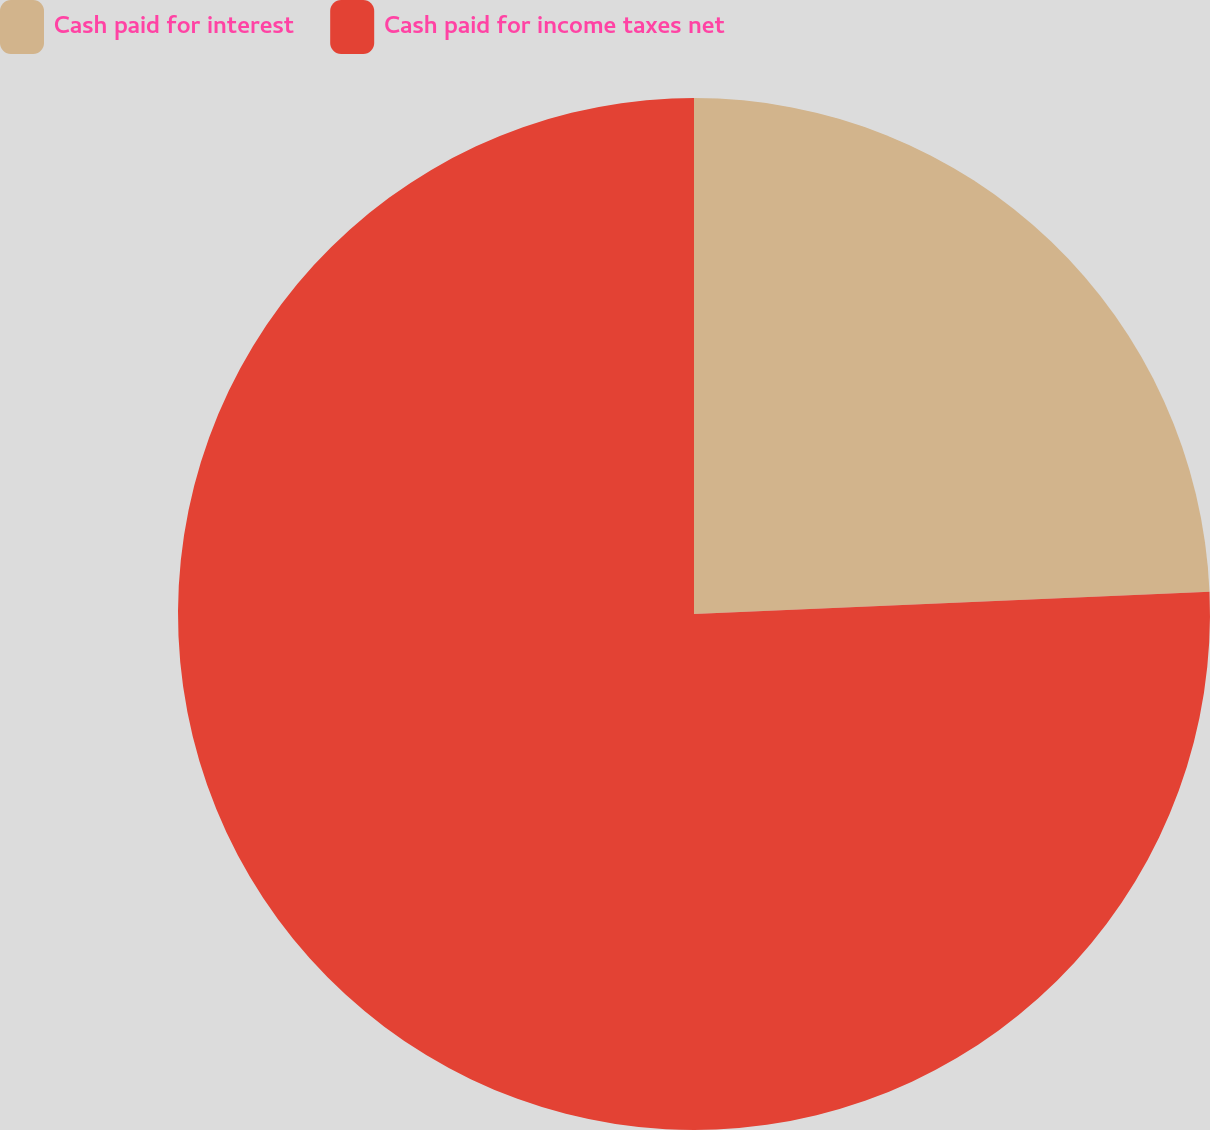Convert chart to OTSL. <chart><loc_0><loc_0><loc_500><loc_500><pie_chart><fcel>Cash paid for interest<fcel>Cash paid for income taxes net<nl><fcel>24.31%<fcel>75.69%<nl></chart> 